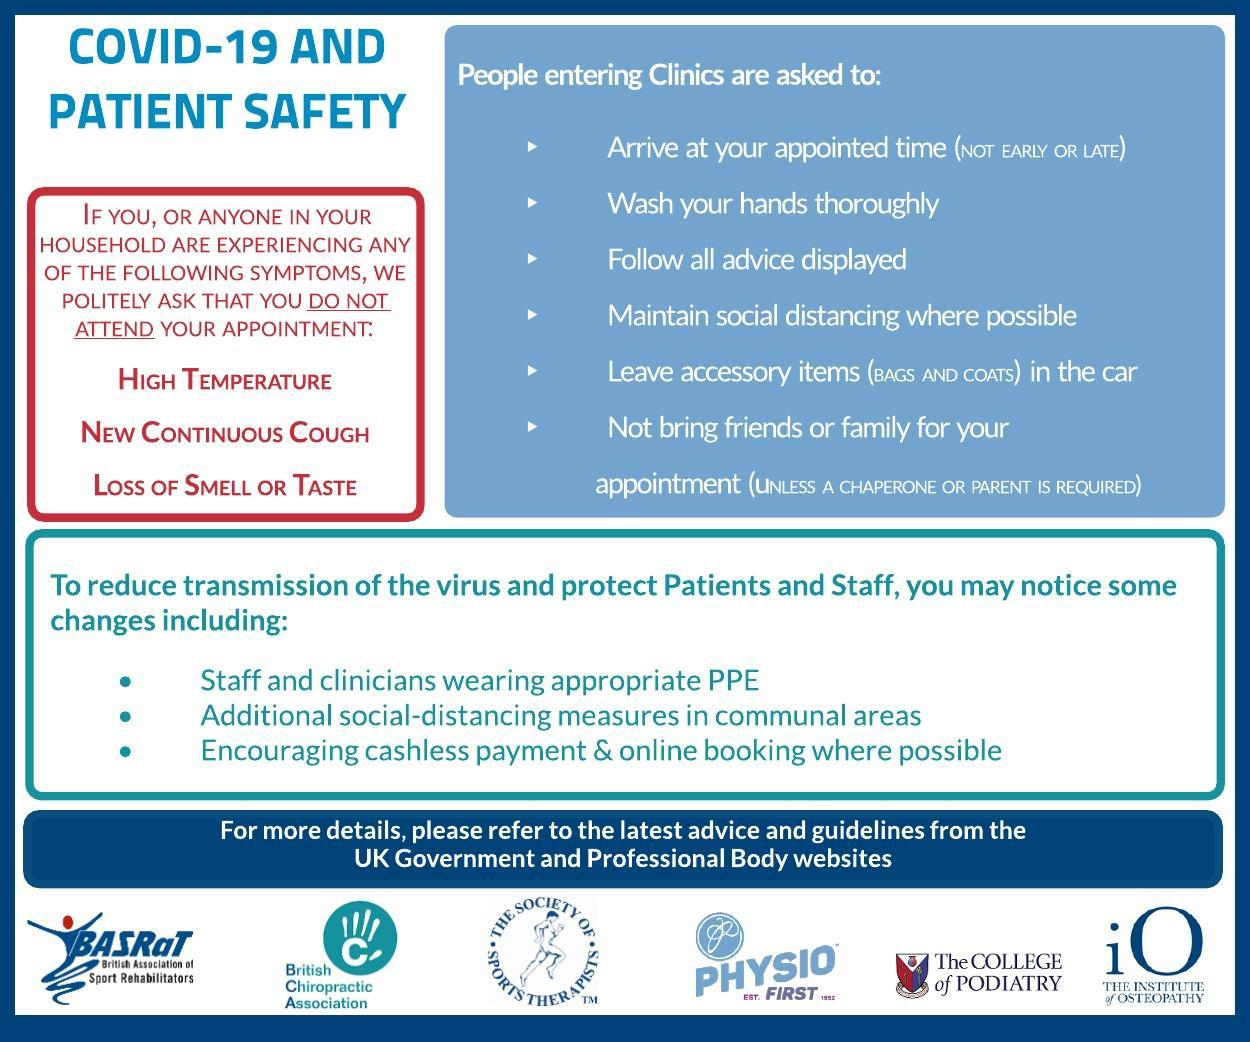What is the protective dress code for staff and clinicians?
Answer the question with a short phrase. PPE Who are 'not allowed' to accompany you on your appointment? Friends, family What type of payment and booking options are encouraged? Cashless payment & online booking When are the patients 'not' expected to arrive for their appointment? Early or late What are the three symptoms mentioned in the red square? High temperature, New continuous cough, Loss of smell or taste The logos of how many institutions as shown below? 6 What should be left in your vehicle before entering the clinic? Accessory items 